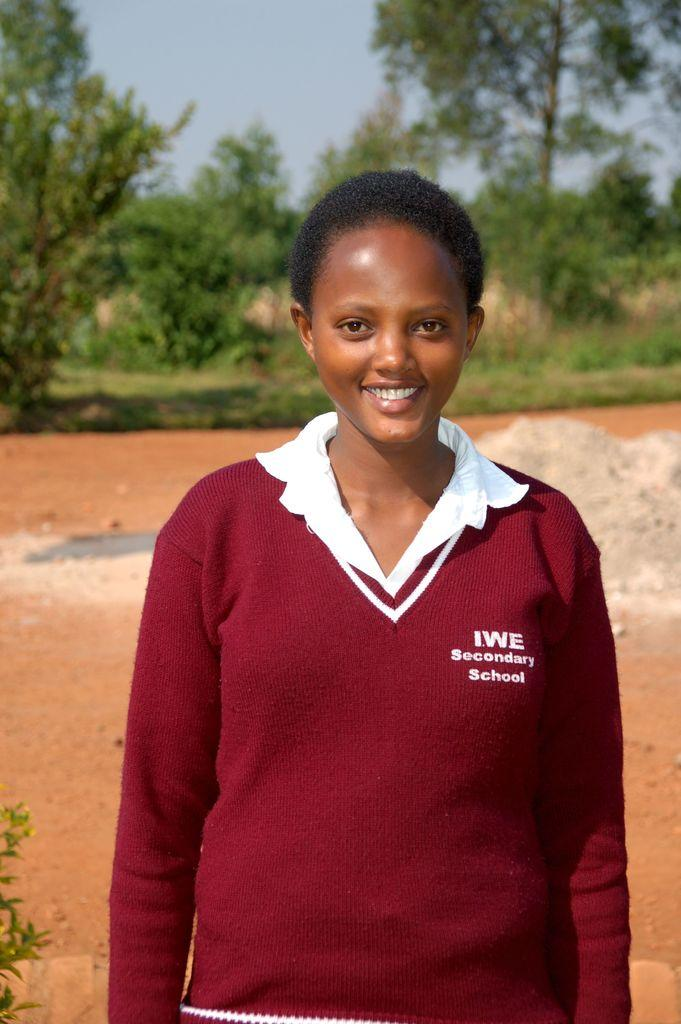What is the main subject of the image? There is a person standing in the image. What is the person doing in the image? The person is smiling. What type of vegetation can be seen in the background of the image? There are green color trees in the background of the image. What is visible at the top of the image? The sky is visible at the top of the image. What type of shop can be seen in the image? There is no shop present in the image; it features a person standing with green trees in the background and the sky visible at the top. 